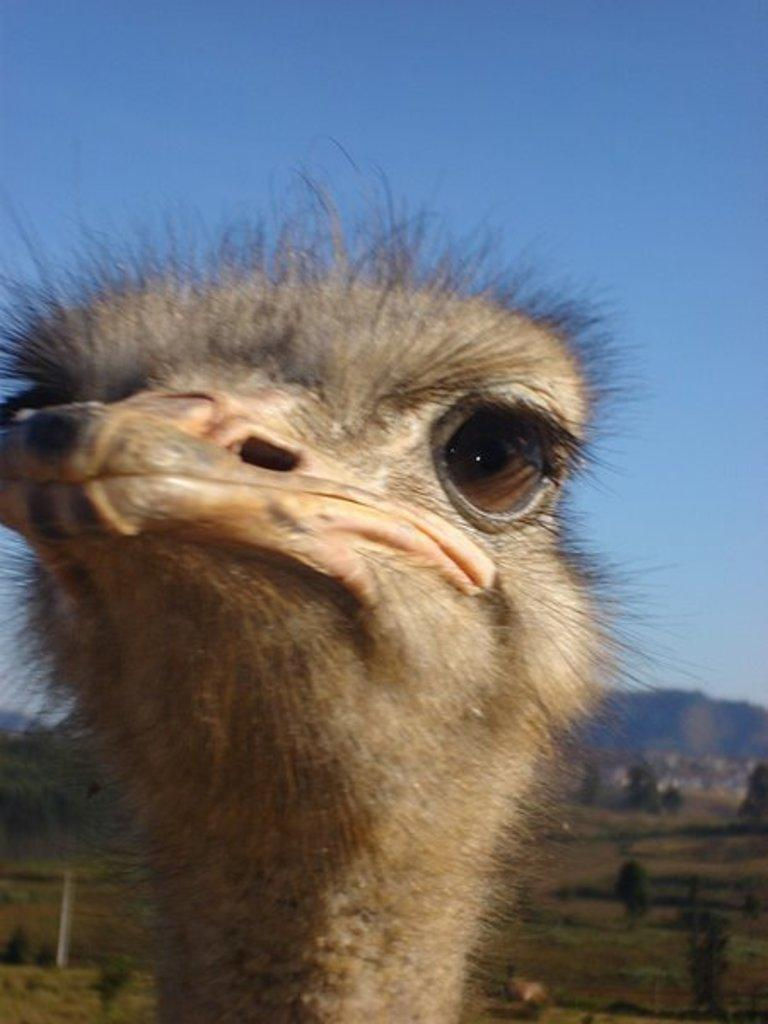What type of animal is in the image? There is an animal in the image, but the specific type cannot be determined from the provided facts. What can be seen on the grassland in the image? There are trees on the grassland in the image. What is visible in the background of the image? There are hills visible in the background of the image. What is visible at the top of the image? The sky is visible at the top of the image. What type of oatmeal is being served to the animal in the image? There is no oatmeal present in the image, and the animal's diet is not mentioned in the provided facts. 